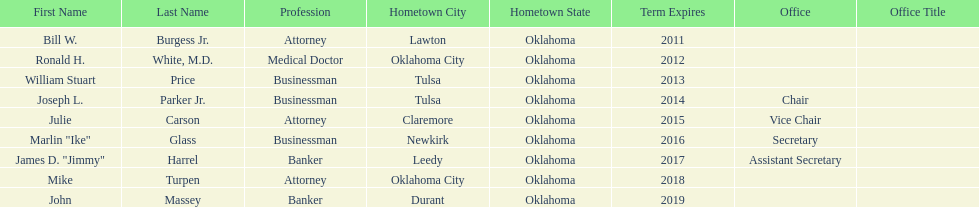What is the total number of state regents who are attorneys? 3. 